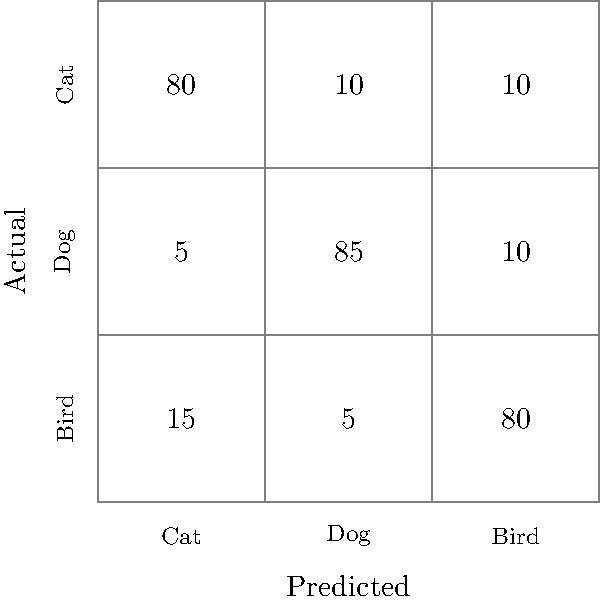As a job seeker interested in machine learning, you're analyzing a confusion matrix for an image classification model. The matrix shows results for classifying images of cats, dogs, and birds. What is the model's accuracy for classifying dog images? To find the accuracy for classifying dog images, we need to follow these steps:

1. Identify the row corresponding to actual dog images in the confusion matrix. This is the second row.

2. Find the total number of actual dog images:
   $5 + 85 + 10 = 100$ dog images in total

3. Identify the number of correctly classified dog images:
   The diagonal element in the dog row shows 85 correctly classified dog images

4. Calculate the accuracy by dividing correct classifications by total:
   Accuracy = $\frac{\text{Correct classifications}}{\text{Total images}} = \frac{85}{100} = 0.85$

5. Convert to percentage:
   $0.85 \times 100\% = 85\%$

Therefore, the model's accuracy for classifying dog images is 85%.
Answer: 85% 